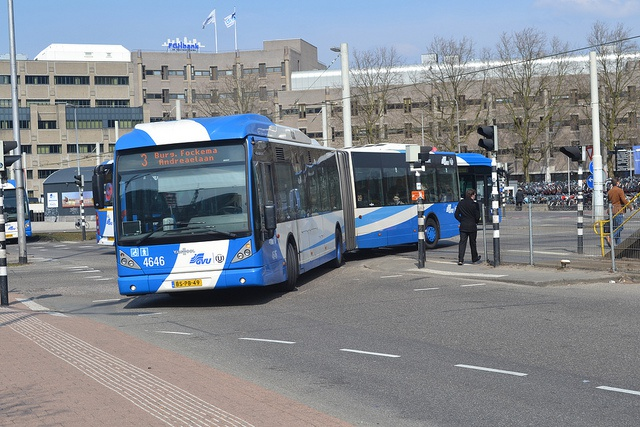Describe the objects in this image and their specific colors. I can see bus in lightblue, black, gray, white, and darkgray tones, bus in lightblue, black, lightgray, blue, and gray tones, people in lightblue, black, gray, and blue tones, people in lightblue, gray, brown, and black tones, and bus in lightblue, blue, white, black, and gray tones in this image. 